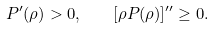<formula> <loc_0><loc_0><loc_500><loc_500>P ^ { \prime } ( \rho ) > 0 , \quad [ \rho P ( \rho ) ] ^ { \prime \prime } \geq 0 .</formula> 